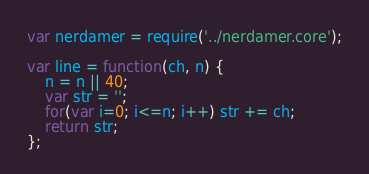Convert code to text. <code><loc_0><loc_0><loc_500><loc_500><_JavaScript_>var nerdamer = require('../nerdamer.core');

var line = function(ch, n) {
    n = n || 40;
    var str = '';
    for(var i=0; i<=n; i++) str += ch;
    return str;
};
</code> 